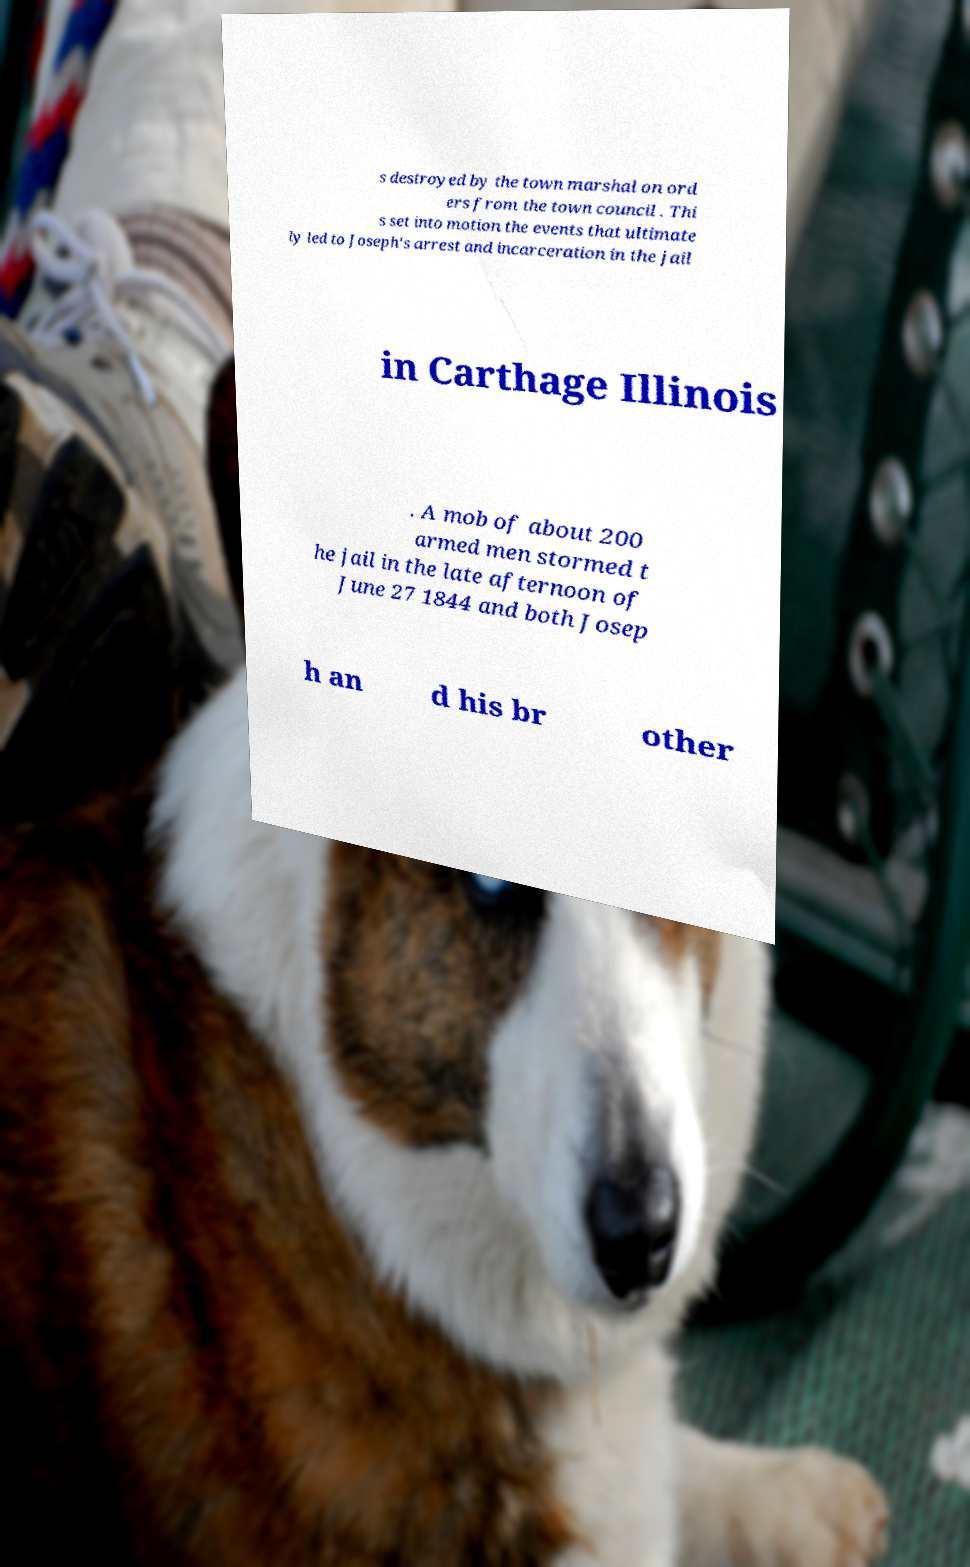Can you accurately transcribe the text from the provided image for me? s destroyed by the town marshal on ord ers from the town council . Thi s set into motion the events that ultimate ly led to Joseph's arrest and incarceration in the jail in Carthage Illinois . A mob of about 200 armed men stormed t he jail in the late afternoon of June 27 1844 and both Josep h an d his br other 